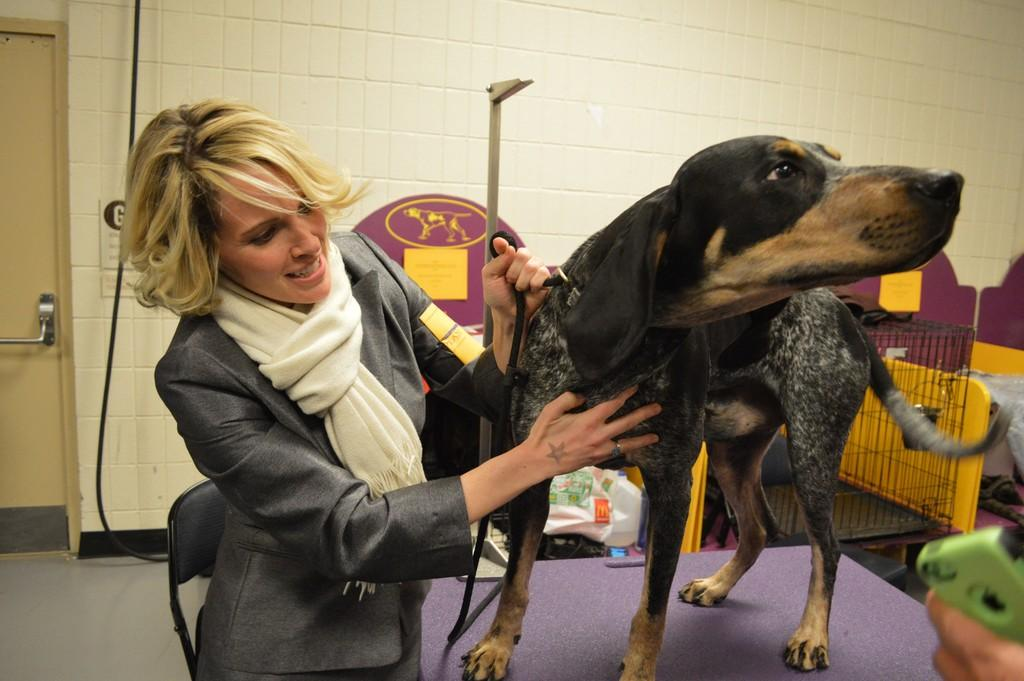What is the setting of the image? The image is of the inside of a room. Is there anyone in the room? Yes, there is a person standing in the room. What is the person doing in the room? The person is holding a dog. Are there any other dogs in the image? Yes, there is a dog on a table. Where is the door located in the room? The door is on the left side of the image. How many ducks are visible in the image? There are no ducks present in the image. What thing is causing the person to experience loss in the image? There is no indication of loss or any specific thing causing it in the image. 